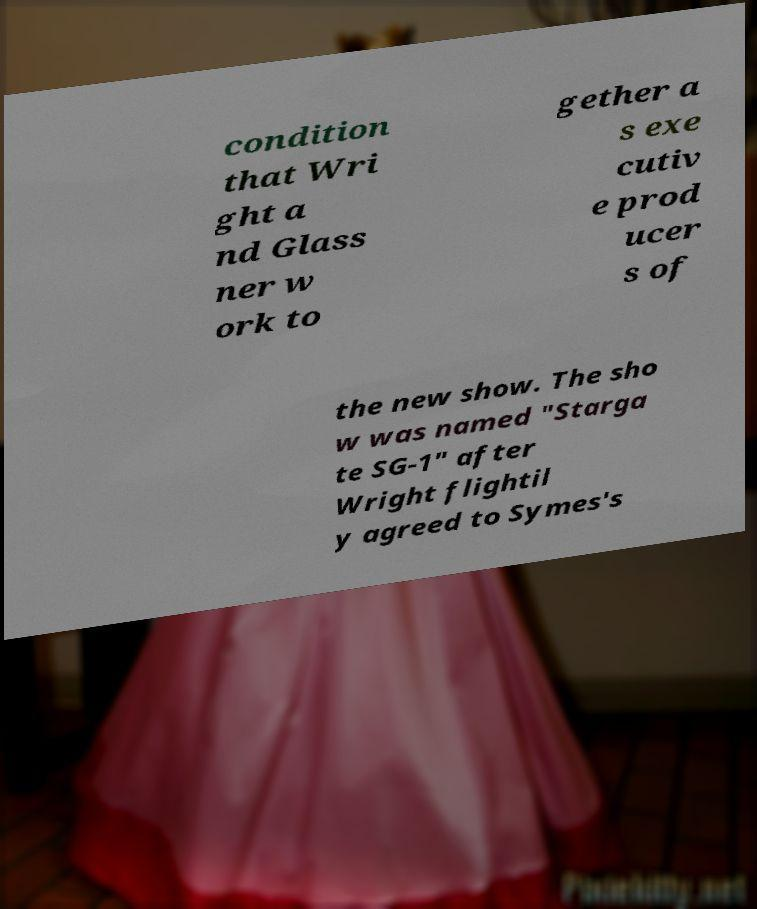Could you assist in decoding the text presented in this image and type it out clearly? condition that Wri ght a nd Glass ner w ork to gether a s exe cutiv e prod ucer s of the new show. The sho w was named "Starga te SG-1" after Wright flightil y agreed to Symes's 